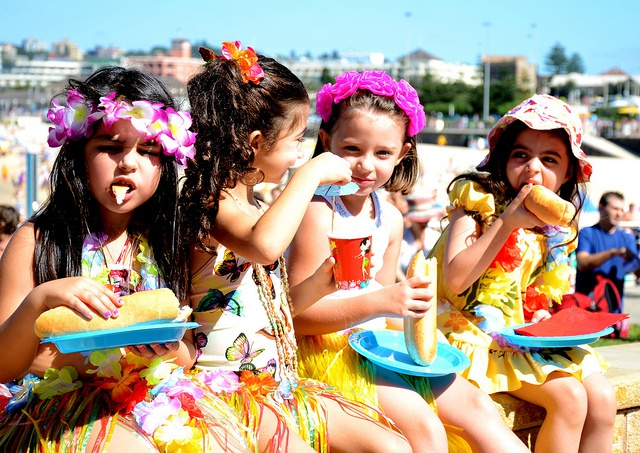Describe the objects in this image and their specific colors. I can see people in lightblue, black, ivory, maroon, and khaki tones, people in lightblue, ivory, black, maroon, and tan tones, people in lightblue, ivory, black, brown, and khaki tones, people in lightblue, ivory, tan, and salmon tones, and people in lightblue, black, blue, and maroon tones in this image. 